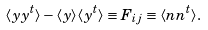<formula> <loc_0><loc_0><loc_500><loc_500>\langle { y y } ^ { t } \rangle - \langle { y } \rangle \langle { y } ^ { t } \rangle \equiv F _ { i j } \equiv \langle { n } { n } ^ { t } \rangle .</formula> 